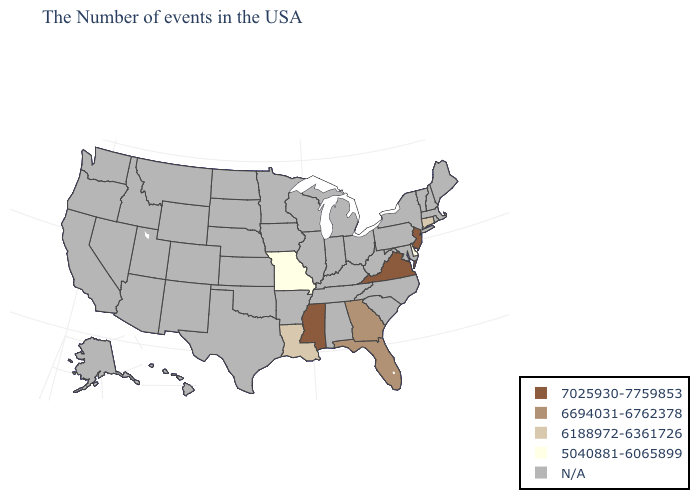What is the value of Virginia?
Answer briefly. 7025930-7759853. Does Mississippi have the highest value in the South?
Answer briefly. Yes. Does Missouri have the lowest value in the USA?
Give a very brief answer. Yes. How many symbols are there in the legend?
Short answer required. 5. Does the map have missing data?
Keep it brief. Yes. Which states have the lowest value in the USA?
Be succinct. Delaware, Missouri. What is the value of Louisiana?
Be succinct. 6188972-6361726. Name the states that have a value in the range 7025930-7759853?
Concise answer only. New Jersey, Virginia, Mississippi. What is the value of West Virginia?
Answer briefly. N/A. 